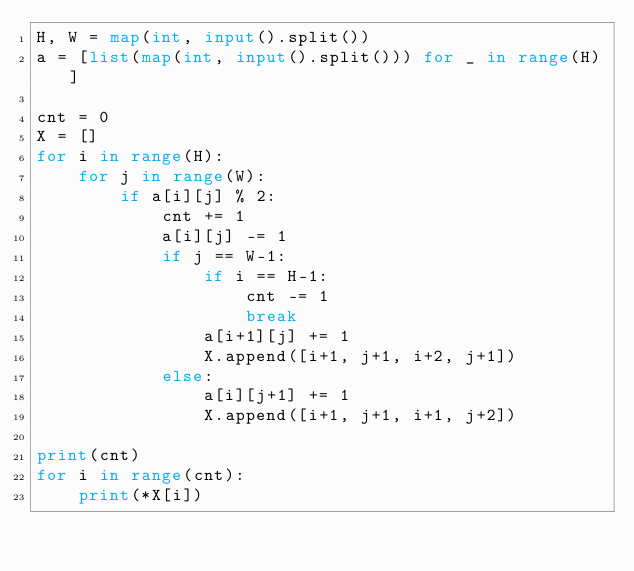Convert code to text. <code><loc_0><loc_0><loc_500><loc_500><_Python_>H, W = map(int, input().split())
a = [list(map(int, input().split())) for _ in range(H)]

cnt = 0
X = []
for i in range(H):
    for j in range(W):
        if a[i][j] % 2:
            cnt += 1
            a[i][j] -= 1
            if j == W-1:
                if i == H-1:
                    cnt -= 1
                    break
                a[i+1][j] += 1
                X.append([i+1, j+1, i+2, j+1])
            else:
                a[i][j+1] += 1
                X.append([i+1, j+1, i+1, j+2])

print(cnt)    
for i in range(cnt):
    print(*X[i])</code> 